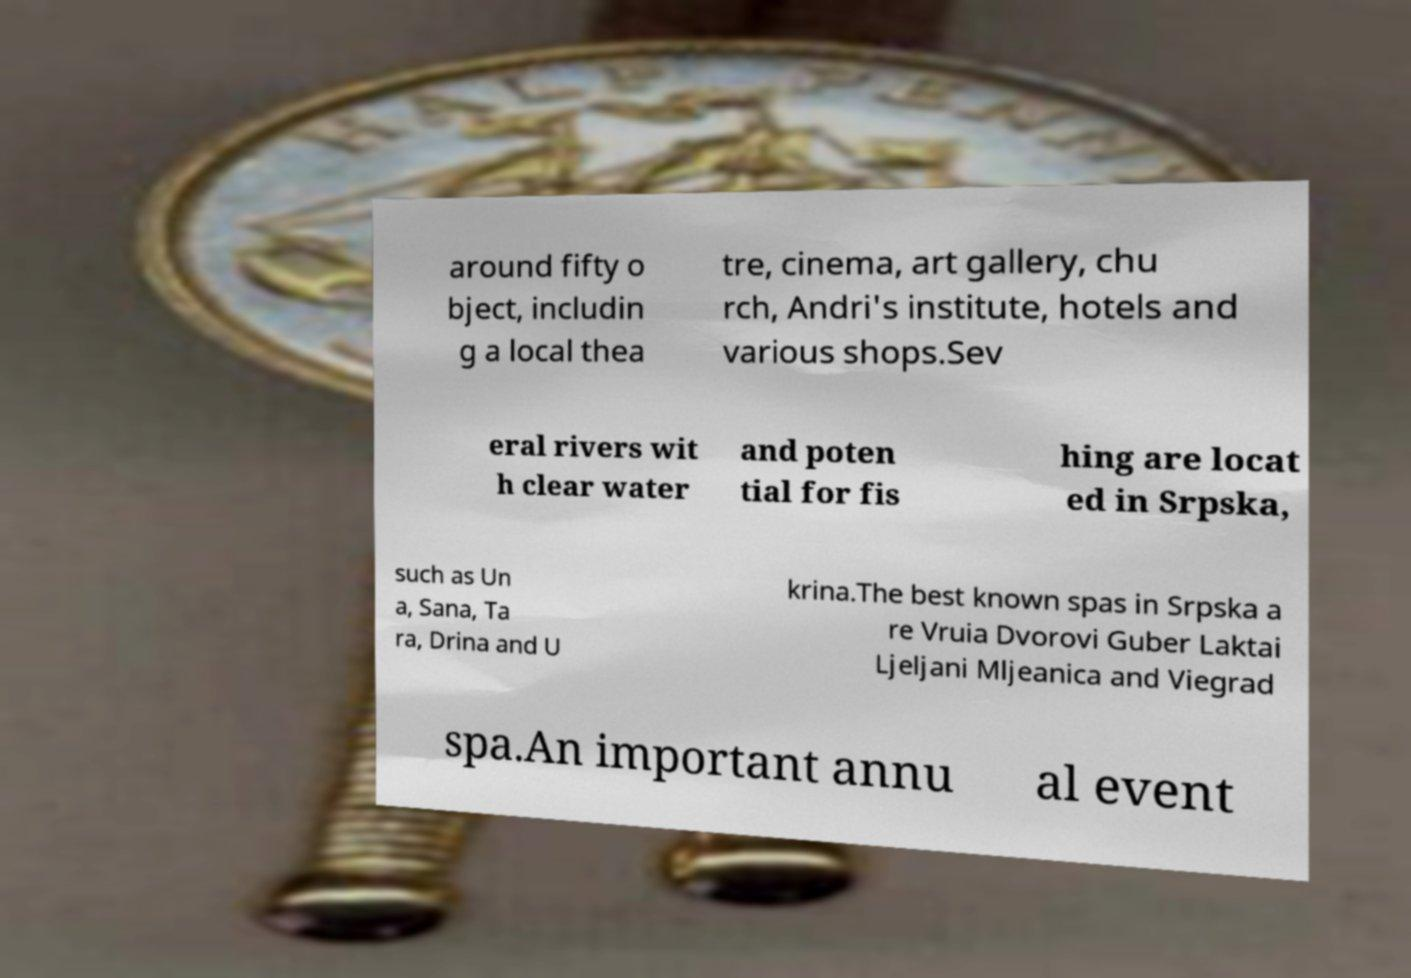Can you read and provide the text displayed in the image?This photo seems to have some interesting text. Can you extract and type it out for me? around fifty o bject, includin g a local thea tre, cinema, art gallery, chu rch, Andri's institute, hotels and various shops.Sev eral rivers wit h clear water and poten tial for fis hing are locat ed in Srpska, such as Un a, Sana, Ta ra, Drina and U krina.The best known spas in Srpska a re Vruia Dvorovi Guber Laktai Ljeljani Mljeanica and Viegrad spa.An important annu al event 